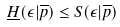<formula> <loc_0><loc_0><loc_500><loc_500>\underline { H } ( \epsilon | \overline { p } ) \leq S ( \epsilon | \overline { p } )</formula> 